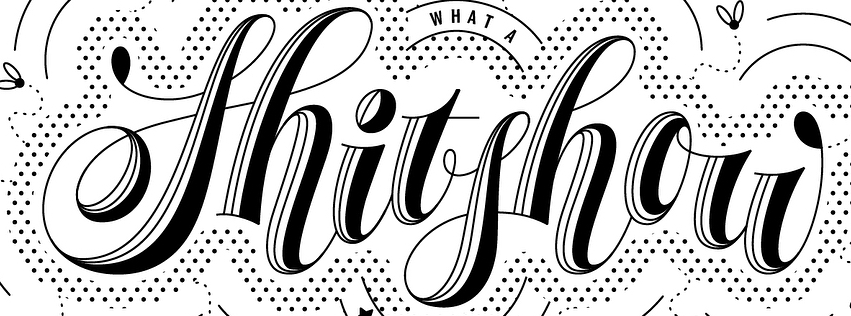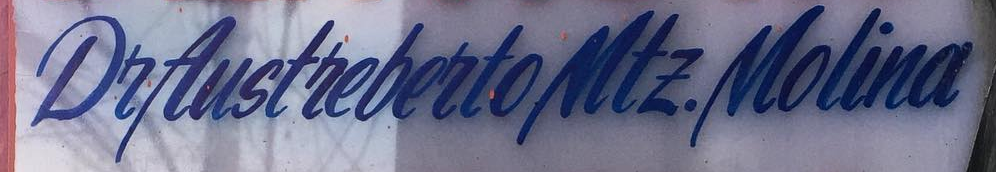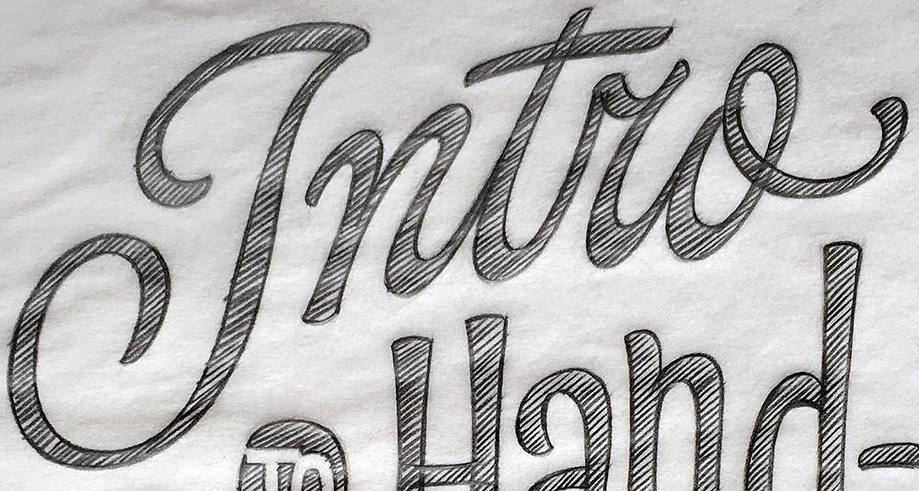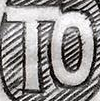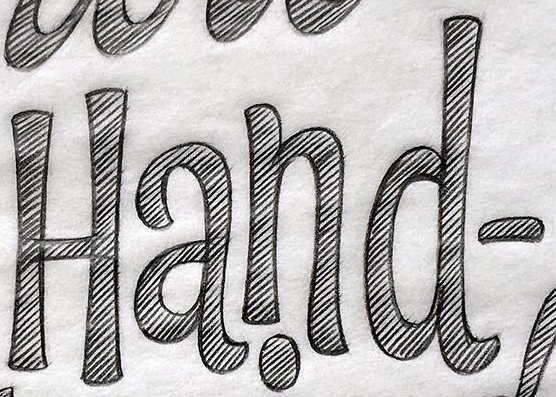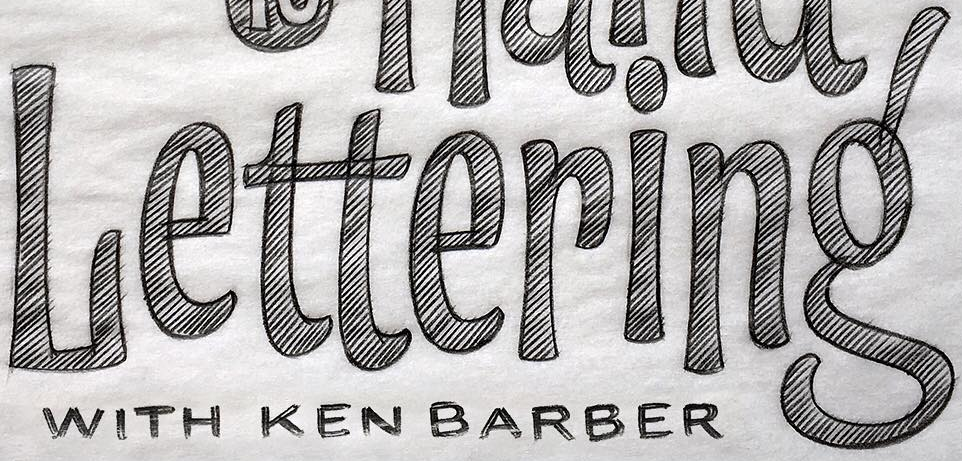What text is displayed in these images sequentially, separated by a semicolon? Shitshou; DeAustrebertoMtE.Molina; Intro; TO; Hand-; Lettering' 